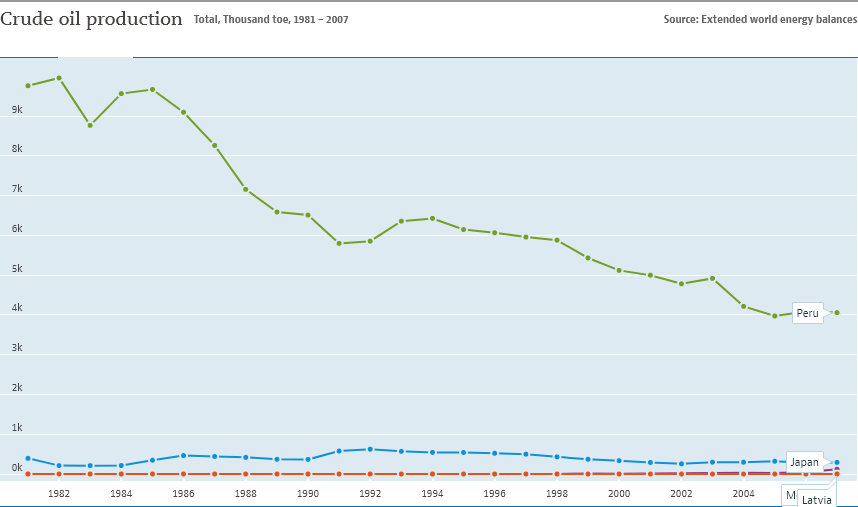Specify some key components in this picture. Peru's data is higher than 9,000 years. Peru's data is displayed in green. 